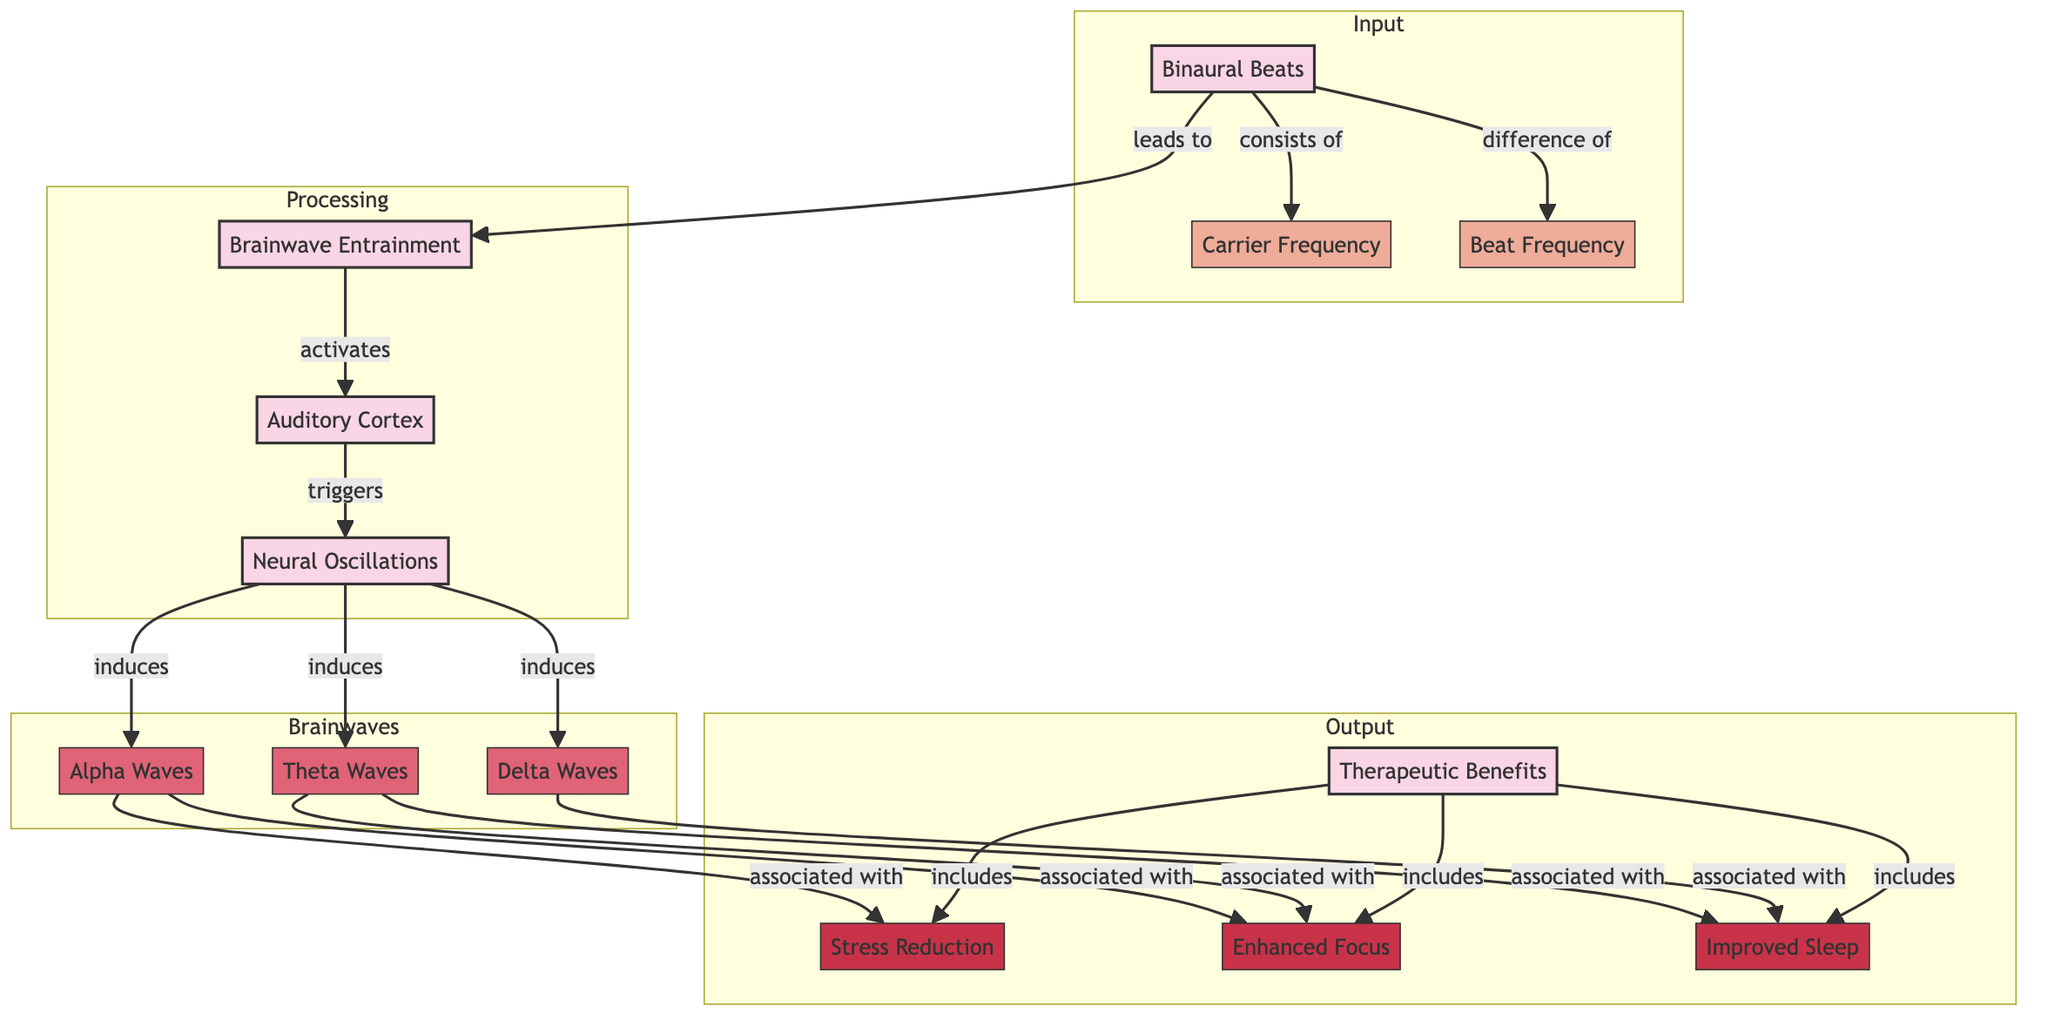What leads to brainwave entrainment? In the diagram, the node "Binaural Beats" has an arrow pointing to "Brainwave Entrainment," indicating that binaural beats are what leads to this process.
Answer: Binaural Beats How many types of brainwaves are induced? The diagram shows three nodes under "Brainwaves": Alpha Waves, Theta Waves, and Delta Waves, which indicates there are three types of brainwaves induced.
Answer: 3 What is associated with Alpha Waves? The diagram shows two arrows leading from "Alpha Waves" to "Stress Reduction" and "Enhanced Focus," indicating these therapeutic benefits are associated with Alpha Waves.
Answer: Stress Reduction, Enhanced Focus What activates the Auditory Cortex? The connection from "Brainwave Entrainment" to "Auditory Cortex" signifies that brainwave entrainment activates the auditory cortex.
Answer: Brainwave Entrainment What includes Improved Sleep? The node "Therapeutic Benefits" has an arrow pointing to "Improved Sleep," meaning that improved sleep is included among the therapeutic benefits specified.
Answer: Therapeutic Benefits How many edges are connected to Neural Oscillations? The "Neural Oscillations" node has three arrows leading to "Alpha Waves," "Theta Waves," and "Delta Waves," indicating that there are three edges connected to this node.
Answer: 3 Which wave type is associated with the most benefits? Both "Theta Waves" and "Delta Waves" are connected to "Improved Sleep," while "Alpha Waves" connect to "Stress Reduction" and "Enhanced Focus." Since "Enhanced Focus" and "Stress Reduction" are counted for Alpha waves, and "Improved Sleep" for Theta and Delta, the overall benefits tied to Alpha Waves are the most (2 benefits versus 1 for others).
Answer: Alpha Waves What kinds of frequencies does Binaural Beats consist of? The diagram states that Binaural Beats consists of "Carrier Frequency" and "Beat Frequency," as indicated by the arrows pointing from Binaural Beats to these two nodes.
Answer: Carrier Frequency, Beat Frequency What triggers Network Neural Oscillations? The arrow leading from "Auditory Cortex" to "Neural Oscillations" indicates that the auditory cortex triggers neural oscillations.
Answer: Auditory Cortex 